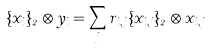<formula> <loc_0><loc_0><loc_500><loc_500>\{ x _ { i } \} _ { 2 } \otimes y _ { i } = \sum _ { j } r _ { i , j } \{ x _ { i , j } \} _ { 2 } \otimes x _ { i , j }</formula> 